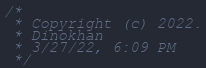Convert code to text. <code><loc_0><loc_0><loc_500><loc_500><_JavaScript_>/*
 * Copyright (c) 2022.
 * Dinokhan
 * 3/27/22, 6:09 PM
 */</code> 